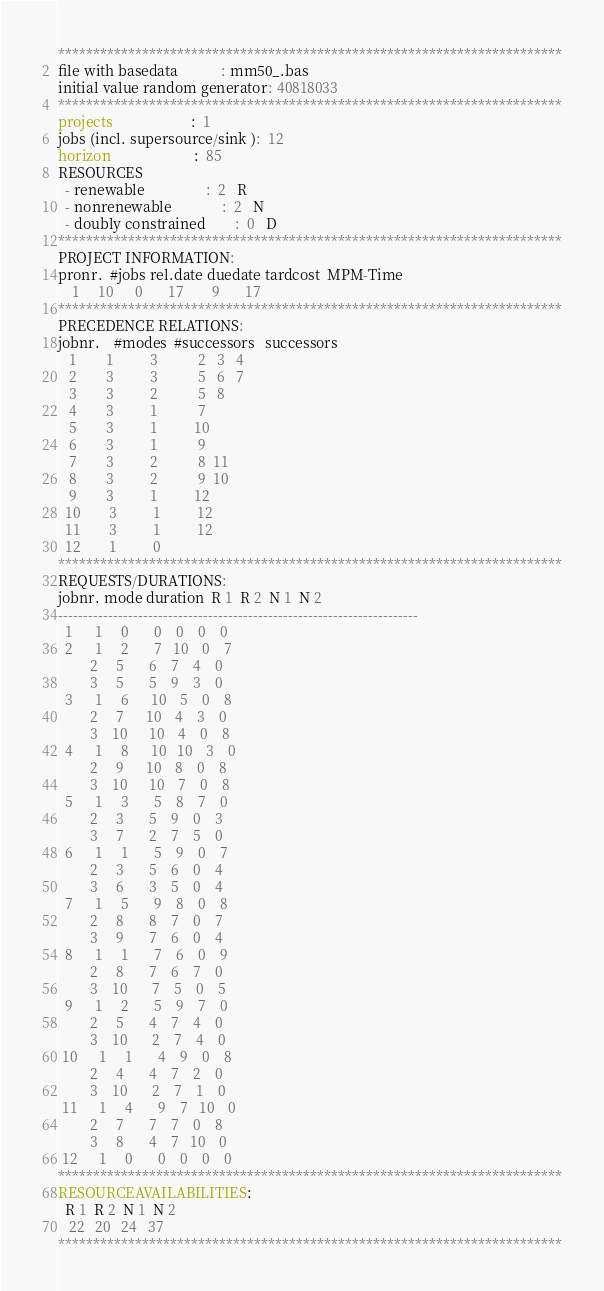<code> <loc_0><loc_0><loc_500><loc_500><_ObjectiveC_>************************************************************************
file with basedata            : mm50_.bas
initial value random generator: 40818033
************************************************************************
projects                      :  1
jobs (incl. supersource/sink ):  12
horizon                       :  85
RESOURCES
  - renewable                 :  2   R
  - nonrenewable              :  2   N
  - doubly constrained        :  0   D
************************************************************************
PROJECT INFORMATION:
pronr.  #jobs rel.date duedate tardcost  MPM-Time
    1     10      0       17        9       17
************************************************************************
PRECEDENCE RELATIONS:
jobnr.    #modes  #successors   successors
   1        1          3           2   3   4
   2        3          3           5   6   7
   3        3          2           5   8
   4        3          1           7
   5        3          1          10
   6        3          1           9
   7        3          2           8  11
   8        3          2           9  10
   9        3          1          12
  10        3          1          12
  11        3          1          12
  12        1          0        
************************************************************************
REQUESTS/DURATIONS:
jobnr. mode duration  R 1  R 2  N 1  N 2
------------------------------------------------------------------------
  1      1     0       0    0    0    0
  2      1     2       7   10    0    7
         2     5       6    7    4    0
         3     5       5    9    3    0
  3      1     6      10    5    0    8
         2     7      10    4    3    0
         3    10      10    4    0    8
  4      1     8      10   10    3    0
         2     9      10    8    0    8
         3    10      10    7    0    8
  5      1     3       5    8    7    0
         2     3       5    9    0    3
         3     7       2    7    5    0
  6      1     1       5    9    0    7
         2     3       5    6    0    4
         3     6       3    5    0    4
  7      1     5       9    8    0    8
         2     8       8    7    0    7
         3     9       7    6    0    4
  8      1     1       7    6    0    9
         2     8       7    6    7    0
         3    10       7    5    0    5
  9      1     2       5    9    7    0
         2     5       4    7    4    0
         3    10       2    7    4    0
 10      1     1       4    9    0    8
         2     4       4    7    2    0
         3    10       2    7    1    0
 11      1     4       9    7   10    0
         2     7       7    7    0    8
         3     8       4    7   10    0
 12      1     0       0    0    0    0
************************************************************************
RESOURCEAVAILABILITIES:
  R 1  R 2  N 1  N 2
   22   20   24   37
************************************************************************
</code> 